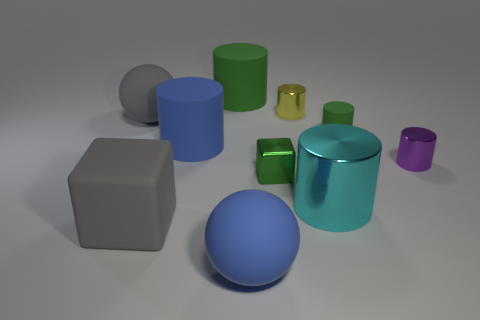What number of other things are the same material as the purple thing?
Your response must be concise. 3. Is there a gray sphere that has the same size as the gray block?
Offer a very short reply. Yes. The sphere that is left of the large blue cylinder is what color?
Make the answer very short. Gray. What shape is the object that is on the right side of the rubber cube and in front of the large cyan cylinder?
Give a very brief answer. Sphere. How many big blue rubber objects are the same shape as the tiny yellow object?
Your answer should be compact. 1. What number of big gray matte cubes are there?
Your answer should be compact. 1. What size is the green thing that is behind the small purple object and to the left of the small green cylinder?
Offer a very short reply. Large. There is a green metallic thing that is the same size as the yellow cylinder; what shape is it?
Offer a terse response. Cube. Is there a small green thing that is in front of the tiny shiny object behind the blue rubber cylinder?
Give a very brief answer. Yes. The other small metal object that is the same shape as the tiny purple object is what color?
Provide a succinct answer. Yellow. 